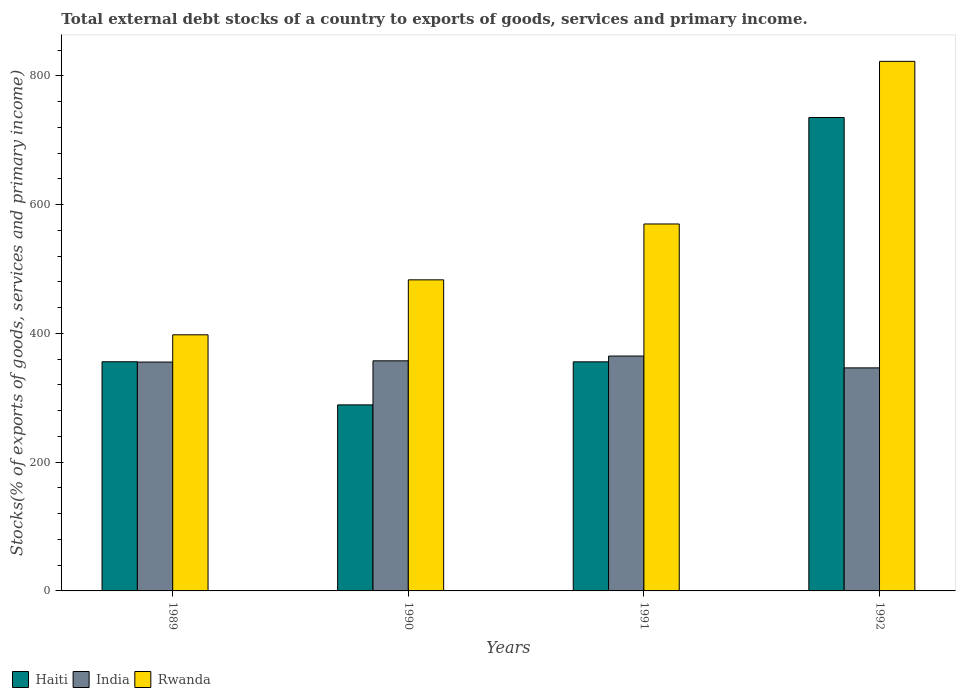How many bars are there on the 3rd tick from the right?
Keep it short and to the point. 3. What is the label of the 3rd group of bars from the left?
Your answer should be compact. 1991. What is the total debt stocks in Rwanda in 1991?
Provide a short and direct response. 570.04. Across all years, what is the maximum total debt stocks in Haiti?
Your response must be concise. 735.43. Across all years, what is the minimum total debt stocks in Rwanda?
Your answer should be compact. 397.87. What is the total total debt stocks in Rwanda in the graph?
Make the answer very short. 2273.82. What is the difference between the total debt stocks in Rwanda in 1989 and that in 1992?
Keep it short and to the point. -424.79. What is the difference between the total debt stocks in Haiti in 1992 and the total debt stocks in India in 1990?
Your answer should be very brief. 377.98. What is the average total debt stocks in Rwanda per year?
Provide a short and direct response. 568.45. In the year 1990, what is the difference between the total debt stocks in Rwanda and total debt stocks in Haiti?
Give a very brief answer. 194.23. What is the ratio of the total debt stocks in Haiti in 1990 to that in 1991?
Ensure brevity in your answer.  0.81. Is the total debt stocks in Haiti in 1991 less than that in 1992?
Ensure brevity in your answer.  Yes. Is the difference between the total debt stocks in Rwanda in 1990 and 1991 greater than the difference between the total debt stocks in Haiti in 1990 and 1991?
Give a very brief answer. No. What is the difference between the highest and the second highest total debt stocks in Haiti?
Ensure brevity in your answer.  379.43. What is the difference between the highest and the lowest total debt stocks in Rwanda?
Offer a very short reply. 424.79. What does the 3rd bar from the right in 1991 represents?
Offer a terse response. Haiti. Is it the case that in every year, the sum of the total debt stocks in Haiti and total debt stocks in Rwanda is greater than the total debt stocks in India?
Make the answer very short. Yes. Are all the bars in the graph horizontal?
Ensure brevity in your answer.  No. How many years are there in the graph?
Provide a succinct answer. 4. Where does the legend appear in the graph?
Offer a very short reply. Bottom left. How many legend labels are there?
Your response must be concise. 3. How are the legend labels stacked?
Provide a short and direct response. Horizontal. What is the title of the graph?
Offer a terse response. Total external debt stocks of a country to exports of goods, services and primary income. What is the label or title of the X-axis?
Provide a short and direct response. Years. What is the label or title of the Y-axis?
Make the answer very short. Stocks(% of exports of goods, services and primary income). What is the Stocks(% of exports of goods, services and primary income) of Haiti in 1989?
Give a very brief answer. 356. What is the Stocks(% of exports of goods, services and primary income) in India in 1989?
Ensure brevity in your answer.  355.55. What is the Stocks(% of exports of goods, services and primary income) of Rwanda in 1989?
Ensure brevity in your answer.  397.87. What is the Stocks(% of exports of goods, services and primary income) in Haiti in 1990?
Provide a short and direct response. 289.01. What is the Stocks(% of exports of goods, services and primary income) of India in 1990?
Give a very brief answer. 357.45. What is the Stocks(% of exports of goods, services and primary income) of Rwanda in 1990?
Ensure brevity in your answer.  483.25. What is the Stocks(% of exports of goods, services and primary income) in Haiti in 1991?
Provide a succinct answer. 355.87. What is the Stocks(% of exports of goods, services and primary income) of India in 1991?
Make the answer very short. 364.87. What is the Stocks(% of exports of goods, services and primary income) in Rwanda in 1991?
Provide a succinct answer. 570.04. What is the Stocks(% of exports of goods, services and primary income) of Haiti in 1992?
Your response must be concise. 735.43. What is the Stocks(% of exports of goods, services and primary income) in India in 1992?
Offer a terse response. 346.48. What is the Stocks(% of exports of goods, services and primary income) in Rwanda in 1992?
Ensure brevity in your answer.  822.66. Across all years, what is the maximum Stocks(% of exports of goods, services and primary income) of Haiti?
Keep it short and to the point. 735.43. Across all years, what is the maximum Stocks(% of exports of goods, services and primary income) of India?
Keep it short and to the point. 364.87. Across all years, what is the maximum Stocks(% of exports of goods, services and primary income) of Rwanda?
Make the answer very short. 822.66. Across all years, what is the minimum Stocks(% of exports of goods, services and primary income) in Haiti?
Provide a succinct answer. 289.01. Across all years, what is the minimum Stocks(% of exports of goods, services and primary income) in India?
Offer a terse response. 346.48. Across all years, what is the minimum Stocks(% of exports of goods, services and primary income) of Rwanda?
Keep it short and to the point. 397.87. What is the total Stocks(% of exports of goods, services and primary income) of Haiti in the graph?
Make the answer very short. 1736.32. What is the total Stocks(% of exports of goods, services and primary income) of India in the graph?
Provide a short and direct response. 1424.35. What is the total Stocks(% of exports of goods, services and primary income) of Rwanda in the graph?
Provide a short and direct response. 2273.82. What is the difference between the Stocks(% of exports of goods, services and primary income) in Haiti in 1989 and that in 1990?
Ensure brevity in your answer.  66.99. What is the difference between the Stocks(% of exports of goods, services and primary income) in India in 1989 and that in 1990?
Your answer should be very brief. -1.91. What is the difference between the Stocks(% of exports of goods, services and primary income) of Rwanda in 1989 and that in 1990?
Offer a very short reply. -85.38. What is the difference between the Stocks(% of exports of goods, services and primary income) in Haiti in 1989 and that in 1991?
Offer a terse response. 0.14. What is the difference between the Stocks(% of exports of goods, services and primary income) in India in 1989 and that in 1991?
Provide a succinct answer. -9.32. What is the difference between the Stocks(% of exports of goods, services and primary income) of Rwanda in 1989 and that in 1991?
Your answer should be very brief. -172.17. What is the difference between the Stocks(% of exports of goods, services and primary income) in Haiti in 1989 and that in 1992?
Provide a succinct answer. -379.43. What is the difference between the Stocks(% of exports of goods, services and primary income) in India in 1989 and that in 1992?
Make the answer very short. 9.06. What is the difference between the Stocks(% of exports of goods, services and primary income) in Rwanda in 1989 and that in 1992?
Provide a succinct answer. -424.79. What is the difference between the Stocks(% of exports of goods, services and primary income) in Haiti in 1990 and that in 1991?
Give a very brief answer. -66.85. What is the difference between the Stocks(% of exports of goods, services and primary income) of India in 1990 and that in 1991?
Your response must be concise. -7.42. What is the difference between the Stocks(% of exports of goods, services and primary income) in Rwanda in 1990 and that in 1991?
Ensure brevity in your answer.  -86.79. What is the difference between the Stocks(% of exports of goods, services and primary income) of Haiti in 1990 and that in 1992?
Your answer should be compact. -446.42. What is the difference between the Stocks(% of exports of goods, services and primary income) of India in 1990 and that in 1992?
Your answer should be compact. 10.97. What is the difference between the Stocks(% of exports of goods, services and primary income) in Rwanda in 1990 and that in 1992?
Provide a succinct answer. -339.41. What is the difference between the Stocks(% of exports of goods, services and primary income) of Haiti in 1991 and that in 1992?
Ensure brevity in your answer.  -379.57. What is the difference between the Stocks(% of exports of goods, services and primary income) in India in 1991 and that in 1992?
Your answer should be very brief. 18.39. What is the difference between the Stocks(% of exports of goods, services and primary income) of Rwanda in 1991 and that in 1992?
Offer a terse response. -252.62. What is the difference between the Stocks(% of exports of goods, services and primary income) in Haiti in 1989 and the Stocks(% of exports of goods, services and primary income) in India in 1990?
Your answer should be very brief. -1.45. What is the difference between the Stocks(% of exports of goods, services and primary income) of Haiti in 1989 and the Stocks(% of exports of goods, services and primary income) of Rwanda in 1990?
Provide a succinct answer. -127.25. What is the difference between the Stocks(% of exports of goods, services and primary income) of India in 1989 and the Stocks(% of exports of goods, services and primary income) of Rwanda in 1990?
Provide a succinct answer. -127.7. What is the difference between the Stocks(% of exports of goods, services and primary income) of Haiti in 1989 and the Stocks(% of exports of goods, services and primary income) of India in 1991?
Your response must be concise. -8.87. What is the difference between the Stocks(% of exports of goods, services and primary income) of Haiti in 1989 and the Stocks(% of exports of goods, services and primary income) of Rwanda in 1991?
Give a very brief answer. -214.04. What is the difference between the Stocks(% of exports of goods, services and primary income) in India in 1989 and the Stocks(% of exports of goods, services and primary income) in Rwanda in 1991?
Provide a short and direct response. -214.49. What is the difference between the Stocks(% of exports of goods, services and primary income) of Haiti in 1989 and the Stocks(% of exports of goods, services and primary income) of India in 1992?
Your response must be concise. 9.52. What is the difference between the Stocks(% of exports of goods, services and primary income) in Haiti in 1989 and the Stocks(% of exports of goods, services and primary income) in Rwanda in 1992?
Provide a succinct answer. -466.66. What is the difference between the Stocks(% of exports of goods, services and primary income) in India in 1989 and the Stocks(% of exports of goods, services and primary income) in Rwanda in 1992?
Offer a very short reply. -467.11. What is the difference between the Stocks(% of exports of goods, services and primary income) in Haiti in 1990 and the Stocks(% of exports of goods, services and primary income) in India in 1991?
Give a very brief answer. -75.86. What is the difference between the Stocks(% of exports of goods, services and primary income) in Haiti in 1990 and the Stocks(% of exports of goods, services and primary income) in Rwanda in 1991?
Provide a short and direct response. -281.03. What is the difference between the Stocks(% of exports of goods, services and primary income) of India in 1990 and the Stocks(% of exports of goods, services and primary income) of Rwanda in 1991?
Offer a terse response. -212.59. What is the difference between the Stocks(% of exports of goods, services and primary income) in Haiti in 1990 and the Stocks(% of exports of goods, services and primary income) in India in 1992?
Ensure brevity in your answer.  -57.47. What is the difference between the Stocks(% of exports of goods, services and primary income) of Haiti in 1990 and the Stocks(% of exports of goods, services and primary income) of Rwanda in 1992?
Your answer should be very brief. -533.65. What is the difference between the Stocks(% of exports of goods, services and primary income) in India in 1990 and the Stocks(% of exports of goods, services and primary income) in Rwanda in 1992?
Make the answer very short. -465.21. What is the difference between the Stocks(% of exports of goods, services and primary income) in Haiti in 1991 and the Stocks(% of exports of goods, services and primary income) in India in 1992?
Provide a succinct answer. 9.38. What is the difference between the Stocks(% of exports of goods, services and primary income) in Haiti in 1991 and the Stocks(% of exports of goods, services and primary income) in Rwanda in 1992?
Ensure brevity in your answer.  -466.79. What is the difference between the Stocks(% of exports of goods, services and primary income) of India in 1991 and the Stocks(% of exports of goods, services and primary income) of Rwanda in 1992?
Your answer should be compact. -457.79. What is the average Stocks(% of exports of goods, services and primary income) of Haiti per year?
Your response must be concise. 434.08. What is the average Stocks(% of exports of goods, services and primary income) of India per year?
Keep it short and to the point. 356.09. What is the average Stocks(% of exports of goods, services and primary income) in Rwanda per year?
Give a very brief answer. 568.45. In the year 1989, what is the difference between the Stocks(% of exports of goods, services and primary income) of Haiti and Stocks(% of exports of goods, services and primary income) of India?
Keep it short and to the point. 0.46. In the year 1989, what is the difference between the Stocks(% of exports of goods, services and primary income) in Haiti and Stocks(% of exports of goods, services and primary income) in Rwanda?
Your answer should be very brief. -41.87. In the year 1989, what is the difference between the Stocks(% of exports of goods, services and primary income) of India and Stocks(% of exports of goods, services and primary income) of Rwanda?
Your answer should be compact. -42.32. In the year 1990, what is the difference between the Stocks(% of exports of goods, services and primary income) of Haiti and Stocks(% of exports of goods, services and primary income) of India?
Your answer should be compact. -68.44. In the year 1990, what is the difference between the Stocks(% of exports of goods, services and primary income) in Haiti and Stocks(% of exports of goods, services and primary income) in Rwanda?
Ensure brevity in your answer.  -194.23. In the year 1990, what is the difference between the Stocks(% of exports of goods, services and primary income) of India and Stocks(% of exports of goods, services and primary income) of Rwanda?
Make the answer very short. -125.79. In the year 1991, what is the difference between the Stocks(% of exports of goods, services and primary income) in Haiti and Stocks(% of exports of goods, services and primary income) in India?
Ensure brevity in your answer.  -9. In the year 1991, what is the difference between the Stocks(% of exports of goods, services and primary income) in Haiti and Stocks(% of exports of goods, services and primary income) in Rwanda?
Offer a very short reply. -214.17. In the year 1991, what is the difference between the Stocks(% of exports of goods, services and primary income) of India and Stocks(% of exports of goods, services and primary income) of Rwanda?
Offer a very short reply. -205.17. In the year 1992, what is the difference between the Stocks(% of exports of goods, services and primary income) of Haiti and Stocks(% of exports of goods, services and primary income) of India?
Your answer should be compact. 388.95. In the year 1992, what is the difference between the Stocks(% of exports of goods, services and primary income) of Haiti and Stocks(% of exports of goods, services and primary income) of Rwanda?
Offer a very short reply. -87.23. In the year 1992, what is the difference between the Stocks(% of exports of goods, services and primary income) of India and Stocks(% of exports of goods, services and primary income) of Rwanda?
Ensure brevity in your answer.  -476.18. What is the ratio of the Stocks(% of exports of goods, services and primary income) in Haiti in 1989 to that in 1990?
Your answer should be compact. 1.23. What is the ratio of the Stocks(% of exports of goods, services and primary income) of India in 1989 to that in 1990?
Keep it short and to the point. 0.99. What is the ratio of the Stocks(% of exports of goods, services and primary income) of Rwanda in 1989 to that in 1990?
Your answer should be compact. 0.82. What is the ratio of the Stocks(% of exports of goods, services and primary income) in Haiti in 1989 to that in 1991?
Give a very brief answer. 1. What is the ratio of the Stocks(% of exports of goods, services and primary income) of India in 1989 to that in 1991?
Your response must be concise. 0.97. What is the ratio of the Stocks(% of exports of goods, services and primary income) in Rwanda in 1989 to that in 1991?
Provide a short and direct response. 0.7. What is the ratio of the Stocks(% of exports of goods, services and primary income) of Haiti in 1989 to that in 1992?
Your answer should be very brief. 0.48. What is the ratio of the Stocks(% of exports of goods, services and primary income) in India in 1989 to that in 1992?
Offer a very short reply. 1.03. What is the ratio of the Stocks(% of exports of goods, services and primary income) of Rwanda in 1989 to that in 1992?
Ensure brevity in your answer.  0.48. What is the ratio of the Stocks(% of exports of goods, services and primary income) in Haiti in 1990 to that in 1991?
Keep it short and to the point. 0.81. What is the ratio of the Stocks(% of exports of goods, services and primary income) in India in 1990 to that in 1991?
Your response must be concise. 0.98. What is the ratio of the Stocks(% of exports of goods, services and primary income) of Rwanda in 1990 to that in 1991?
Keep it short and to the point. 0.85. What is the ratio of the Stocks(% of exports of goods, services and primary income) of Haiti in 1990 to that in 1992?
Offer a very short reply. 0.39. What is the ratio of the Stocks(% of exports of goods, services and primary income) in India in 1990 to that in 1992?
Make the answer very short. 1.03. What is the ratio of the Stocks(% of exports of goods, services and primary income) of Rwanda in 1990 to that in 1992?
Offer a very short reply. 0.59. What is the ratio of the Stocks(% of exports of goods, services and primary income) of Haiti in 1991 to that in 1992?
Keep it short and to the point. 0.48. What is the ratio of the Stocks(% of exports of goods, services and primary income) of India in 1991 to that in 1992?
Give a very brief answer. 1.05. What is the ratio of the Stocks(% of exports of goods, services and primary income) of Rwanda in 1991 to that in 1992?
Ensure brevity in your answer.  0.69. What is the difference between the highest and the second highest Stocks(% of exports of goods, services and primary income) in Haiti?
Provide a short and direct response. 379.43. What is the difference between the highest and the second highest Stocks(% of exports of goods, services and primary income) of India?
Provide a short and direct response. 7.42. What is the difference between the highest and the second highest Stocks(% of exports of goods, services and primary income) of Rwanda?
Your answer should be compact. 252.62. What is the difference between the highest and the lowest Stocks(% of exports of goods, services and primary income) of Haiti?
Your response must be concise. 446.42. What is the difference between the highest and the lowest Stocks(% of exports of goods, services and primary income) of India?
Provide a succinct answer. 18.39. What is the difference between the highest and the lowest Stocks(% of exports of goods, services and primary income) of Rwanda?
Make the answer very short. 424.79. 